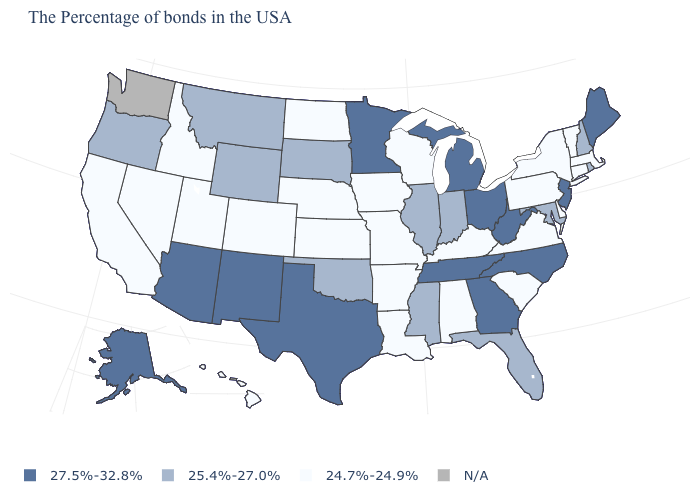Is the legend a continuous bar?
Quick response, please. No. What is the value of Connecticut?
Answer briefly. 24.7%-24.9%. Which states have the highest value in the USA?
Concise answer only. Maine, New Jersey, North Carolina, West Virginia, Ohio, Georgia, Michigan, Tennessee, Minnesota, Texas, New Mexico, Arizona, Alaska. How many symbols are there in the legend?
Concise answer only. 4. What is the value of Wyoming?
Write a very short answer. 25.4%-27.0%. What is the value of Pennsylvania?
Write a very short answer. 24.7%-24.9%. Does the map have missing data?
Short answer required. Yes. Is the legend a continuous bar?
Be succinct. No. Name the states that have a value in the range 27.5%-32.8%?
Be succinct. Maine, New Jersey, North Carolina, West Virginia, Ohio, Georgia, Michigan, Tennessee, Minnesota, Texas, New Mexico, Arizona, Alaska. Name the states that have a value in the range 25.4%-27.0%?
Answer briefly. Rhode Island, New Hampshire, Maryland, Florida, Indiana, Illinois, Mississippi, Oklahoma, South Dakota, Wyoming, Montana, Oregon. Name the states that have a value in the range N/A?
Write a very short answer. Washington. Does the first symbol in the legend represent the smallest category?
Quick response, please. No. Name the states that have a value in the range 24.7%-24.9%?
Quick response, please. Massachusetts, Vermont, Connecticut, New York, Delaware, Pennsylvania, Virginia, South Carolina, Kentucky, Alabama, Wisconsin, Louisiana, Missouri, Arkansas, Iowa, Kansas, Nebraska, North Dakota, Colorado, Utah, Idaho, Nevada, California, Hawaii. Name the states that have a value in the range 24.7%-24.9%?
Keep it brief. Massachusetts, Vermont, Connecticut, New York, Delaware, Pennsylvania, Virginia, South Carolina, Kentucky, Alabama, Wisconsin, Louisiana, Missouri, Arkansas, Iowa, Kansas, Nebraska, North Dakota, Colorado, Utah, Idaho, Nevada, California, Hawaii. What is the lowest value in states that border Wyoming?
Answer briefly. 24.7%-24.9%. 